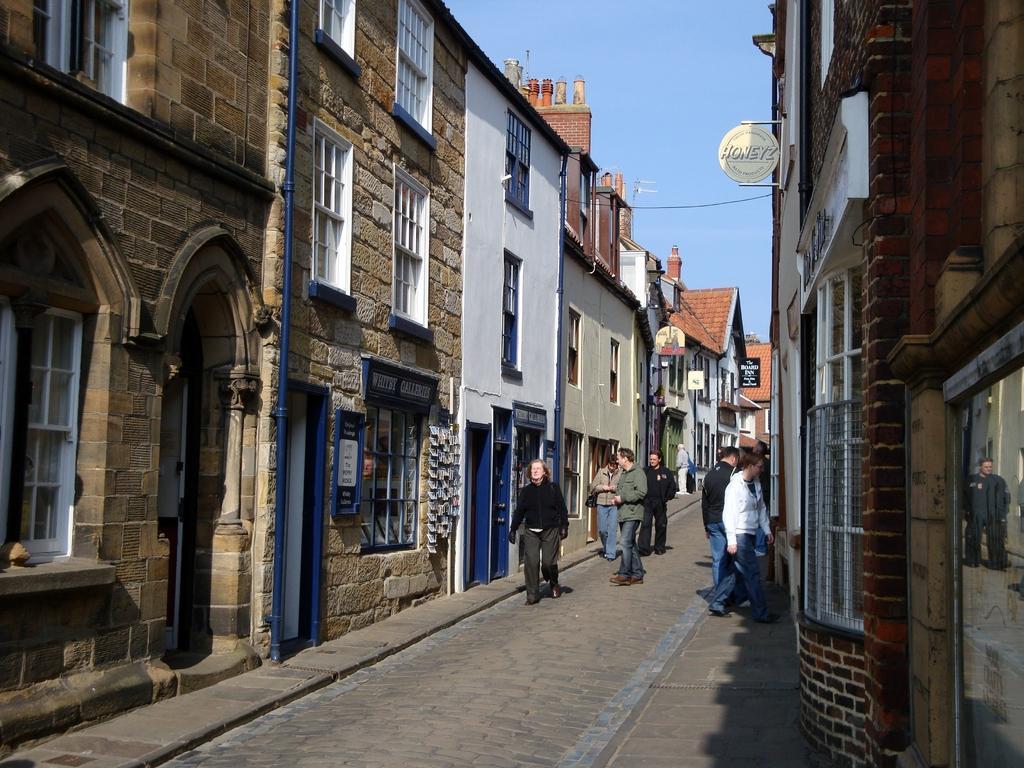Describe this image in one or two sentences. In this image we can see a group of people on the pathway. We can also see a group of buildings with windows, the sign boards with some text on them and the sky which looks cloudy. 